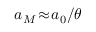<formula> <loc_0><loc_0><loc_500><loc_500>a _ { M } \, \approx \, a _ { 0 } / \theta</formula> 